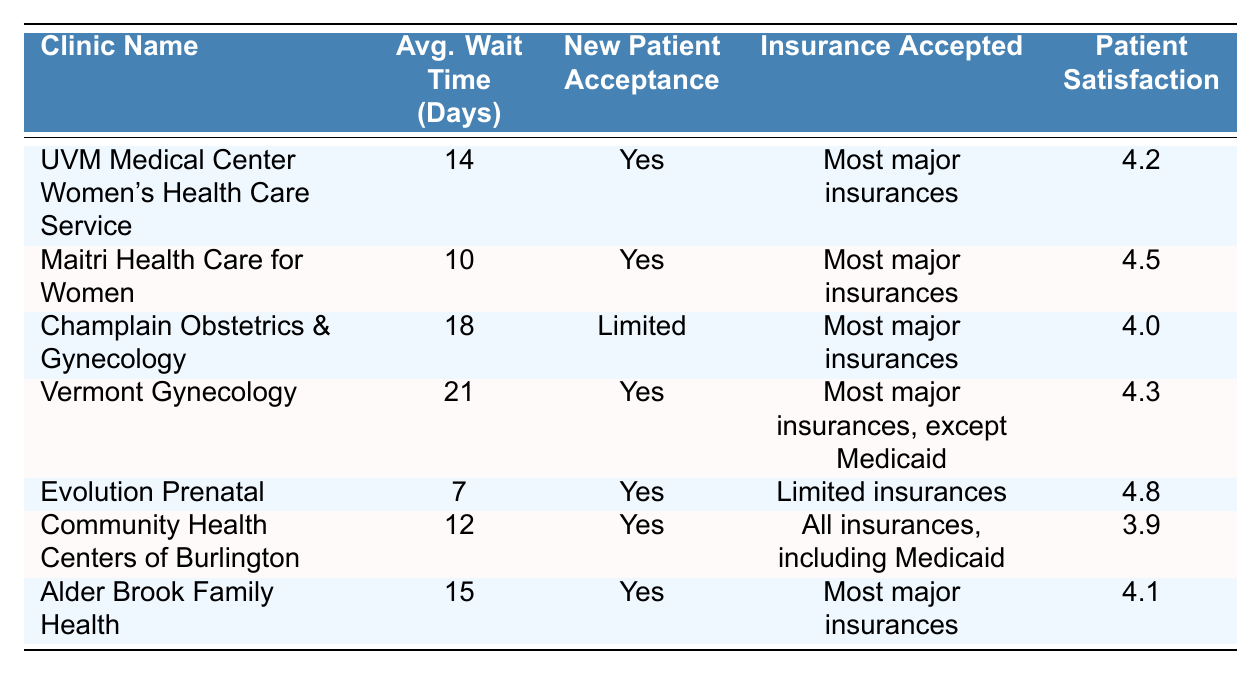What is the average wait time for appointments at Evolution Prenatal? The table indicates that the average wait time for appointments at Evolution Prenatal is listed directly as 7 days.
Answer: 7 days Which clinic has the longest average wait time? By examining the average wait times in the table, Vermont Gynecology has the highest wait time at 21 days.
Answer: Vermont Gynecology Are new patients accepted at Champlain Obstetrics & Gynecology? The table states that new patient acceptance at Champlain Obstetrics & Gynecology is marked as "Limited," indicating that not all new patients may be accepted.
Answer: Limited What is the patient satisfaction rating for Community Health Centers of Burlington? The table shows that the patient satisfaction rating for Community Health Centers of Burlington is 3.9.
Answer: 3.9 If I prefer a clinic that accepts all types of insurance, which clinic should I choose? The table lists Community Health Centers of Burlington as accepting all insurances, including Medicaid, which meets the preference stated.
Answer: Community Health Centers of Burlington What is the difference in average wait time between Evolution Prenatal and Maitri Health Care for Women? Evolution Prenatal has an average wait time of 7 days, while Maitri Health Care for Women has an average wait time of 10 days. The difference is 10 - 7 = 3 days.
Answer: 3 days Which clinics accept most major insurances? According to the table, the clinics that accept most major insurances are UVM Medical Center Women's Health Care Service, Maitri Health Care for Women, Champlain Obstetrics & Gynecology, Vermont Gynecology, and Alder Brook Family Health.
Answer: 5 clinics What is the average patient satisfaction rating for the clinics that accept limited insurances? Only Evolution Prenatal (4.8) and Community Health Centers of Burlington (3.9) accept limited insurances. The average is calculated as (4.8 + 3.9) / 2 = 4.35.
Answer: 4.35 Is there a clinic with an average wait time less than 10 days that accepts all insurances? The table reveals that Evolution Prenatal has an average wait time of 7 days but it does not accept all insurances. Community Health Centers of Burlington accepts all insurances but has a wait time of 12 days. Thus, there is no clinic that meets both criteria.
Answer: No What is the highest patient satisfaction rating among the listed clinics? Reviewing the patient satisfaction ratings, Evolution Prenatal has the highest rating at 4.8.
Answer: 4.8 